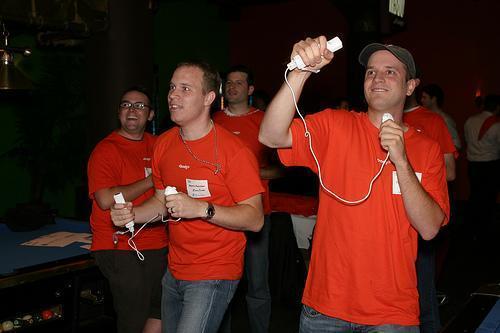How many people are there?
Give a very brief answer. 5. 